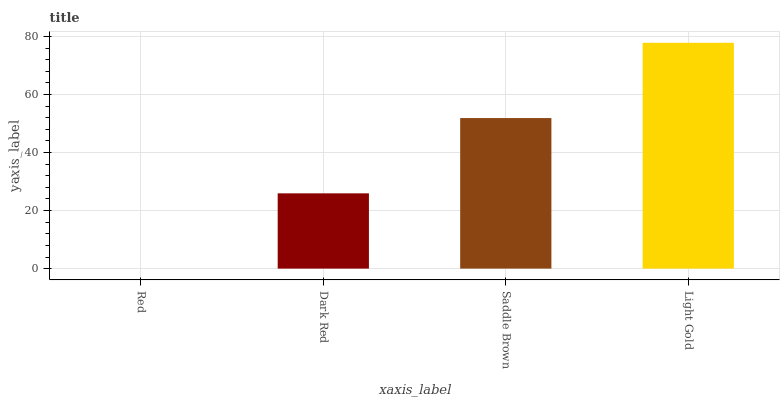Is Dark Red the minimum?
Answer yes or no. No. Is Dark Red the maximum?
Answer yes or no. No. Is Dark Red greater than Red?
Answer yes or no. Yes. Is Red less than Dark Red?
Answer yes or no. Yes. Is Red greater than Dark Red?
Answer yes or no. No. Is Dark Red less than Red?
Answer yes or no. No. Is Saddle Brown the high median?
Answer yes or no. Yes. Is Dark Red the low median?
Answer yes or no. Yes. Is Light Gold the high median?
Answer yes or no. No. Is Saddle Brown the low median?
Answer yes or no. No. 